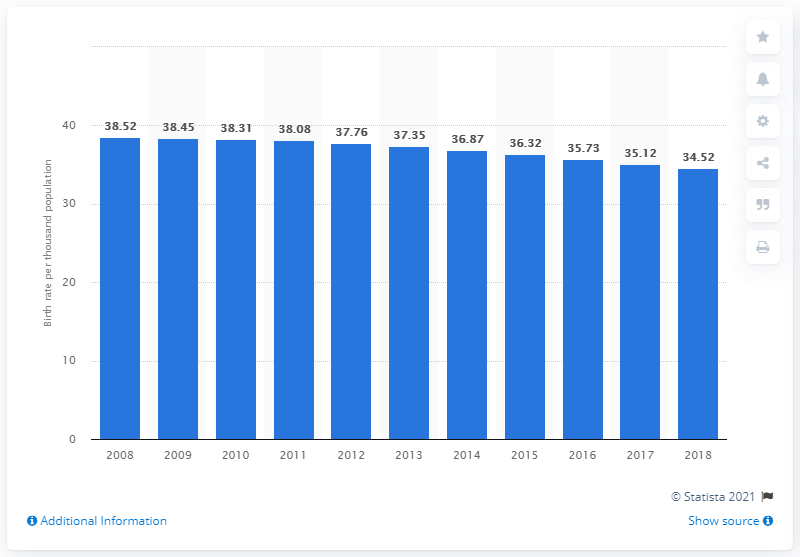Point out several critical features in this image. The crude birth rate in Senegal in 2018 was 34.52. 